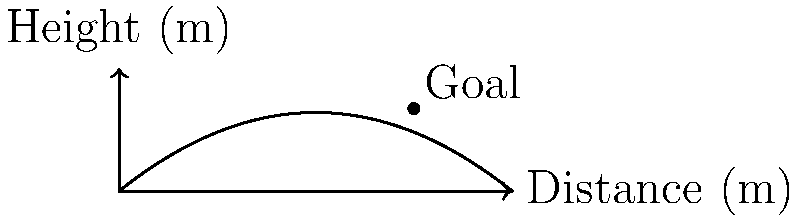In a crucial match between Al-Ahli Club and Al-Tilal SC, you're analyzing a legendary long-range shot. The ball's trajectory can be modeled by the function $h(x) = -0.05x^2 + 0.8x$, where $h$ is the height in meters and $x$ is the horizontal distance in meters. The goal is located 12 meters away from the point of the shot. What is the angle, in degrees, at which the ball enters the goal? To find the angle at which the ball enters the goal, we need to follow these steps:

1) First, we need to find the height of the ball when it reaches the goal. We can do this by plugging $x = 12$ into our function:

   $h(12) = -0.05(12)^2 + 0.8(12) = -7.2 + 9.6 = 2.4$ meters

2) Now we have a right triangle with the following properties:
   - The base is 12 meters (horizontal distance to the goal)
   - The height is 2.4 meters (height of the ball at the goal)

3) To find the angle, we can use the tangent function:

   $\tan(\theta) = \frac{\text{opposite}}{\text{adjacent}} = \frac{2.4}{12} = 0.2$

4) To get the angle, we need to use the inverse tangent (arctangent) function:

   $\theta = \arctan(0.2)$

5) Convert this to degrees:

   $\theta = \arctan(0.2) \cdot \frac{180}{\pi} \approx 11.31$ degrees

Therefore, the ball enters the goal at an angle of approximately 11.31 degrees.
Answer: $11.31°$ 